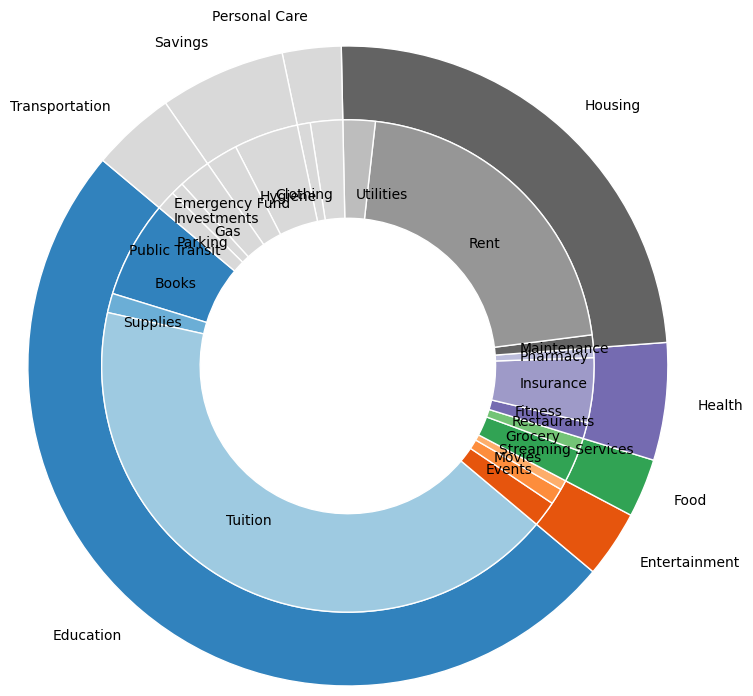What is the total monthly amount spent on Housing? To find the total monthly amount spent on Housing, sum up the amounts from the subcategories under Housing: Rent ($500) + Utilities ($50) + Maintenance ($20).
Answer: $570 Which category has the highest monthly expenditure and what is its amount? From the outer pie chart, you can see that Housing has the largest section. Adding up the monthly expenses: Rent ($500) + Utilities ($50) + Maintenance ($20) gives Housing a total of $570.
Answer: Housing, $570 Which category has the smallest allocation, and what subcategories does it include? Examining the outer pie chart, find the smallest wedge, which belongs to Personal Care and Savings. Checking these: Personal Care has $70 (Clothing $50 + Hygiene $20) and Savings has $150 (Emergency Fund $100 + Investments $50). Thus, Personal Care has the smallest total of $70.
Answer: Personal Care (Clothing, Hygiene) How much more is spent on Rent than on Grocery in a month? From the chart, the monthly amount spent on Rent is $500, and the weekly amount spent on Grocery is $50. Converting weekly to monthly (4 weeks), Grocery totals $200. So, Rent ($500) - Grocery ($200) = $300 more is spent on Rent.
Answer: $300 Compare the Education subcategory with the highest amount to the Health subcategory with the highest amount. Which is higher and by how much? For Education, the highest subcategory is Tuition ($1000 per Semester, let's assume 3 semesters for simplicity, summed it would be $1000/3 = $333.33 monthly, over the 3 semesters). For Health, the highest subcategory is Insurance ($100 monthly). Comparing them, $333.33 (Education) - $100 (Health) = $233.33, with Education's Tuition being higher.
Answer: Education's Tuition, by $233.33 What is the total amount allocated to Entertainment, and how frequently are these expenses? Sum up the subcategories under Entertainment: Streaming Services ($15) + Movies ($25) + Events ($40). All these expenses are monthly. Adding them up: $15 + $25 + $40 = $80 per month.
Answer: $80 per month What is the monthly cost for Public Transit and Gas combined under Transportation? From the chart, the monthly amount for Public Transit is $30 and for Gas is $50. Adding them together: $30 + $50 = $80.
Answer: $80 How does the amount spent on Insurance compare to the amount spent on Streaming Services plus Movies? Which is higher and by how much? The monthly amount spent on Insurance is $100. The sum of Streaming Services ($15) and Movies ($25) is $40. So, $100 - $40 = $60, with Insurance being higher.
Answer: Insurance, by $60 